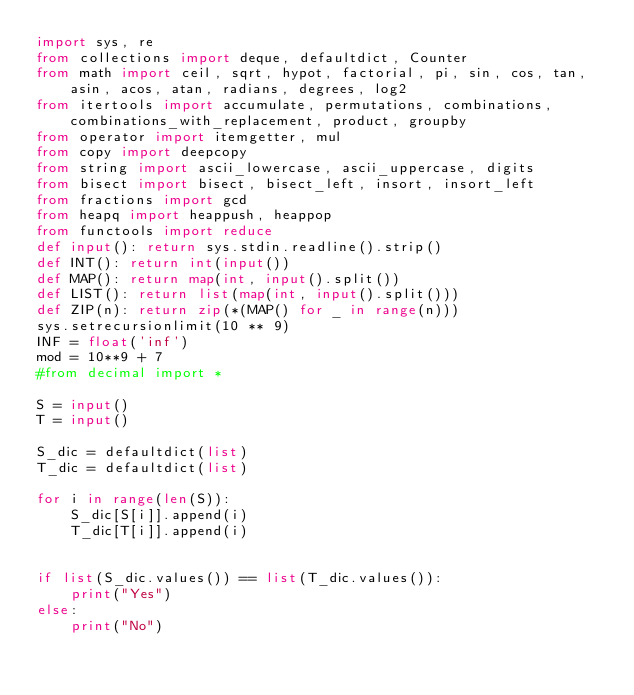<code> <loc_0><loc_0><loc_500><loc_500><_Python_>import sys, re
from collections import deque, defaultdict, Counter
from math import ceil, sqrt, hypot, factorial, pi, sin, cos, tan, asin, acos, atan, radians, degrees, log2
from itertools import accumulate, permutations, combinations, combinations_with_replacement, product, groupby
from operator import itemgetter, mul
from copy import deepcopy
from string import ascii_lowercase, ascii_uppercase, digits
from bisect import bisect, bisect_left, insort, insort_left
from fractions import gcd
from heapq import heappush, heappop
from functools import reduce
def input(): return sys.stdin.readline().strip()
def INT(): return int(input())
def MAP(): return map(int, input().split())
def LIST(): return list(map(int, input().split()))
def ZIP(n): return zip(*(MAP() for _ in range(n)))
sys.setrecursionlimit(10 ** 9)
INF = float('inf')
mod = 10**9 + 7
#from decimal import *

S = input()
T = input()

S_dic = defaultdict(list)
T_dic = defaultdict(list)

for i in range(len(S)):
	S_dic[S[i]].append(i)
	T_dic[T[i]].append(i)


if list(S_dic.values()) == list(T_dic.values()):
	print("Yes")
else:
	print("No")</code> 